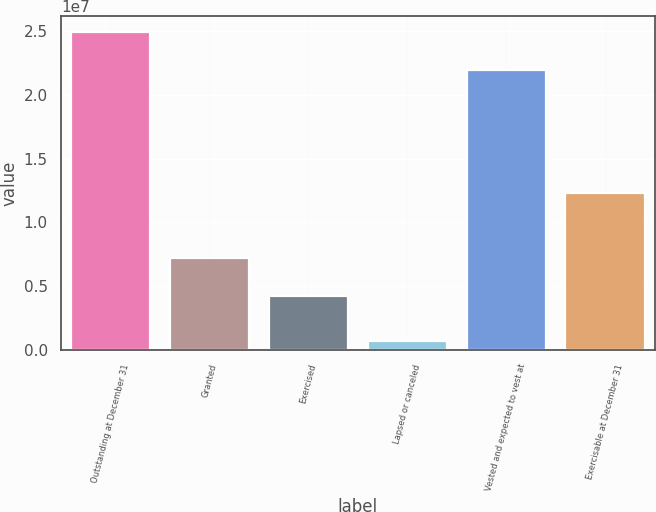<chart> <loc_0><loc_0><loc_500><loc_500><bar_chart><fcel>Outstanding at December 31<fcel>Granted<fcel>Exercised<fcel>Lapsed or canceled<fcel>Vested and expected to vest at<fcel>Exercisable at December 31<nl><fcel>2.49661e+07<fcel>7.17693e+06<fcel>4.1903e+06<fcel>703132<fcel>2.19795e+07<fcel>1.22889e+07<nl></chart> 